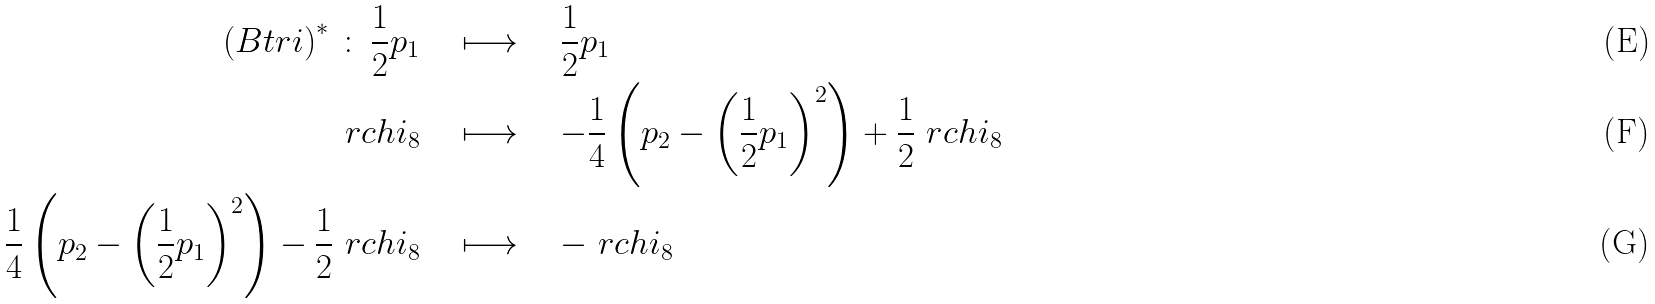<formula> <loc_0><loc_0><loc_500><loc_500>\left ( B t r i \right ) ^ { \ast } \, \colon \, \frac { 1 } { 2 } p _ { 1 } \quad & \longmapsto \quad \frac { 1 } { 2 } p _ { 1 } \\ \ r c h i _ { 8 } \quad & \longmapsto \quad - \frac { 1 } { 4 } \left ( p _ { 2 } - \left ( \frac { 1 } { 2 } p _ { 1 } \right ) ^ { 2 } \right ) + \frac { 1 } { 2 } \ r c h i _ { 8 } \\ \frac { 1 } { 4 } \left ( p _ { 2 } - \left ( \frac { 1 } { 2 } p _ { 1 } \right ) ^ { 2 } \right ) - \frac { 1 } { 2 } \ r c h i _ { 8 } \quad & \longmapsto \quad - \ r c h i _ { 8 }</formula> 